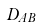<formula> <loc_0><loc_0><loc_500><loc_500>D _ { A B }</formula> 